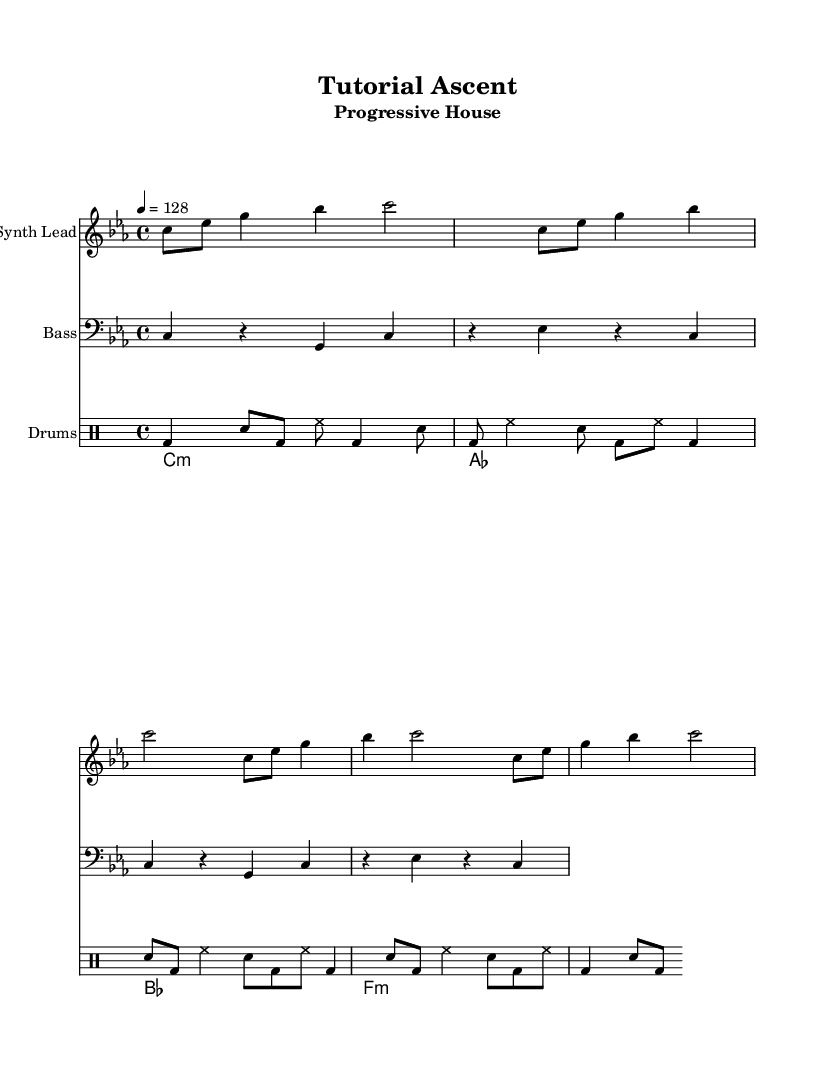What is the key signature of this music? The key signature is C minor, indicated by the presence of three flats (B♭, E♭, and A♭) in the music.
Answer: C minor What is the time signature of this music? The time signature is 4/4, which is typically indicated at the beginning of the score, specifying four beats per measure.
Answer: 4/4 What is the tempo of this music? The tempo is indicated as 128 beats per minute, shown in the tempo markings at the beginning of the score.
Answer: 128 How many measures are in the synth lead part? The synth lead part contains four measures, each represented by the vertical lines separating the notes in the score.
Answer: 4 Which section of the music features the bass line? The bass line is indicated on a separate staff marked with the clef sign, specifically designed for bass instruments and is labeled as "Bass."
Answer: Bass What style of music is represented in this sheet music? The style is specified in the subtitle of the sheet music, reflecting the characteristics of the genre with progressive builds.
Answer: Progressive House How does the structure of the music support a gradual learning build? The structure of repeated patterns in all parts (synth, bass, drums) allows for gradual complexity, enabling learners to process the information in manageable increments, akin to lesson modules.
Answer: Gradual complexity 